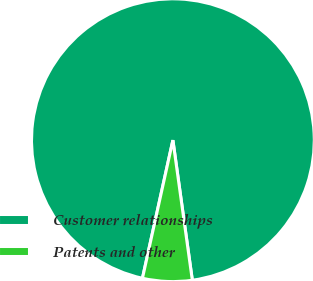Convert chart. <chart><loc_0><loc_0><loc_500><loc_500><pie_chart><fcel>Customer relationships<fcel>Patents and other<nl><fcel>94.35%<fcel>5.65%<nl></chart> 